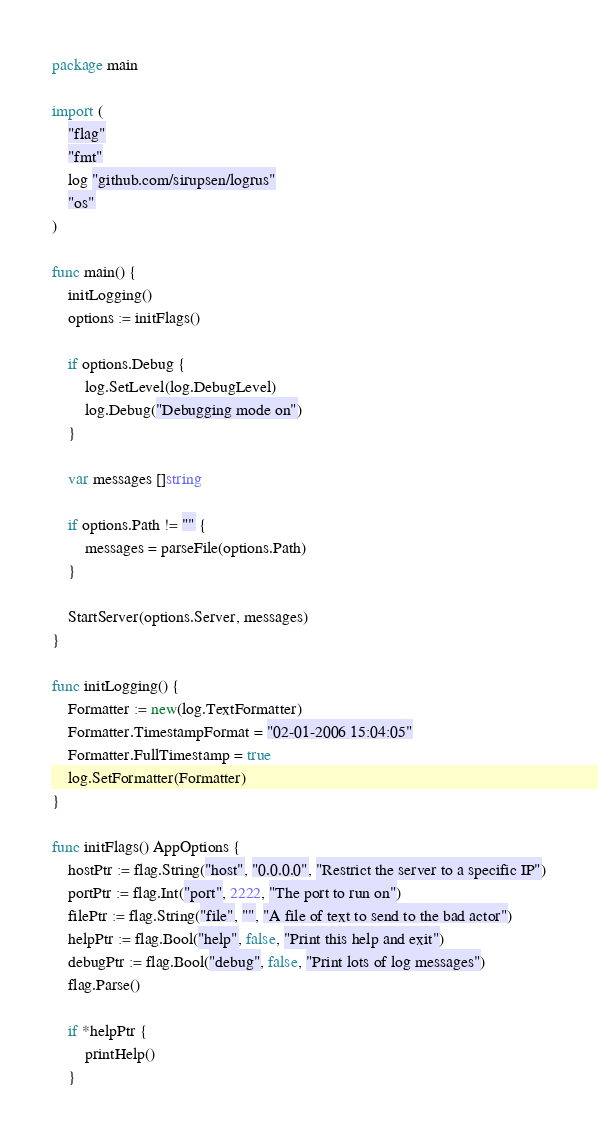Convert code to text. <code><loc_0><loc_0><loc_500><loc_500><_Go_>package main

import (
	"flag"
	"fmt"
	log "github.com/sirupsen/logrus"
	"os"
)

func main() {
	initLogging()
	options := initFlags()

	if options.Debug {
		log.SetLevel(log.DebugLevel)
		log.Debug("Debugging mode on")
	}

	var messages []string

	if options.Path != "" {
		messages = parseFile(options.Path)
	}

	StartServer(options.Server, messages)
}

func initLogging() {
	Formatter := new(log.TextFormatter)
	Formatter.TimestampFormat = "02-01-2006 15:04:05"
	Formatter.FullTimestamp = true
	log.SetFormatter(Formatter)
}

func initFlags() AppOptions {
	hostPtr := flag.String("host", "0.0.0.0", "Restrict the server to a specific IP")
	portPtr := flag.Int("port", 2222, "The port to run on")
	filePtr := flag.String("file", "", "A file of text to send to the bad actor")
	helpPtr := flag.Bool("help", false, "Print this help and exit")
	debugPtr := flag.Bool("debug", false, "Print lots of log messages")
	flag.Parse()

	if *helpPtr {
		printHelp()
	}
</code> 